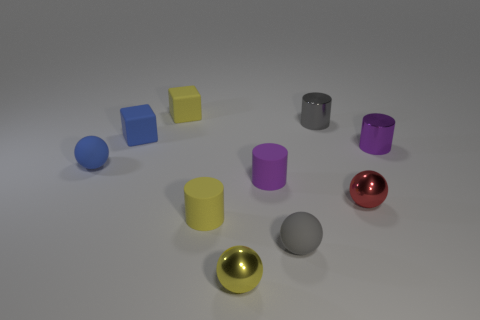Can you tell me which objects have a reflective surface? Certainly! The two spheres in the image, one gold and one red, have highly reflective surfaces that you can observe due to the light and reflections visible on them. Are there any repeating colors among the cylinders? Yes, indeed. We have two cylinders sharing a similar shade of purple. 